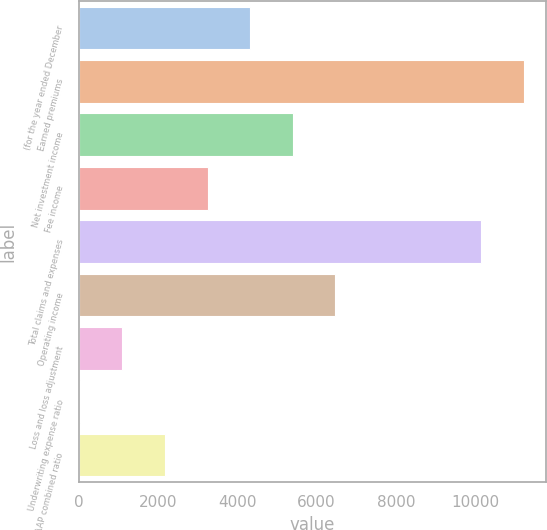<chart> <loc_0><loc_0><loc_500><loc_500><bar_chart><fcel>(for the year ended December<fcel>Earned premiums<fcel>Net investment income<fcel>Fee income<fcel>Total claims and expenses<fcel>Operating income<fcel>Loss and loss adjustment<fcel>Underwriting expense ratio<fcel>GAAP combined ratio<nl><fcel>4325.72<fcel>11230.4<fcel>5399.1<fcel>3252.34<fcel>10157<fcel>6472.48<fcel>1105.58<fcel>32.2<fcel>2178.96<nl></chart> 